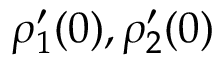<formula> <loc_0><loc_0><loc_500><loc_500>\rho _ { 1 } ^ { \prime } ( 0 ) , \rho _ { 2 } ^ { \prime } ( 0 )</formula> 